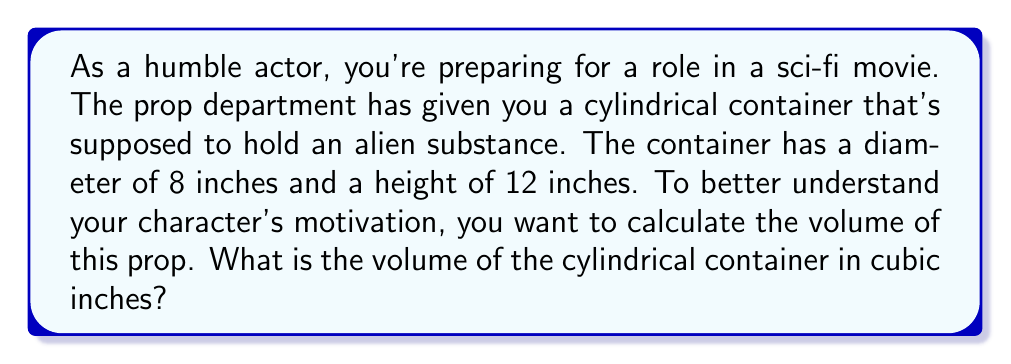What is the answer to this math problem? To find the volume of a cylinder, we use the formula:

$$V = \pi r^2 h$$

Where:
$V$ = volume
$r$ = radius of the base
$h$ = height of the cylinder

Given:
- Diameter = 8 inches
- Height = 12 inches

Step 1: Calculate the radius
The radius is half the diameter:
$r = \frac{8}{2} = 4$ inches

Step 2: Apply the formula
$$\begin{align*}
V &= \pi r^2 h \\
&= \pi (4^2) (12) \\
&= \pi (16) (12) \\
&= 192\pi
\end{align*}$$

Step 3: Calculate the final value
$V = 192\pi \approx 603.19$ cubic inches

[asy]
import geometry;

size(200);

real r = 4;
real h = 12;

path base = circle((0,0), r);
path top = circle((0,h), r);

draw(base);
draw(top);
draw((r,0)--(r,h));
draw((-r,0)--(-r,h));

label("8\"", (0,-r), S);
label("12\"", (r+0.5,h/2), E);

[/asy]
Answer: The volume of the cylindrical container is $192\pi$ or approximately 603.19 cubic inches. 